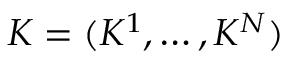Convert formula to latex. <formula><loc_0><loc_0><loc_500><loc_500>K = ( K ^ { 1 } , \dots , K ^ { N } )</formula> 